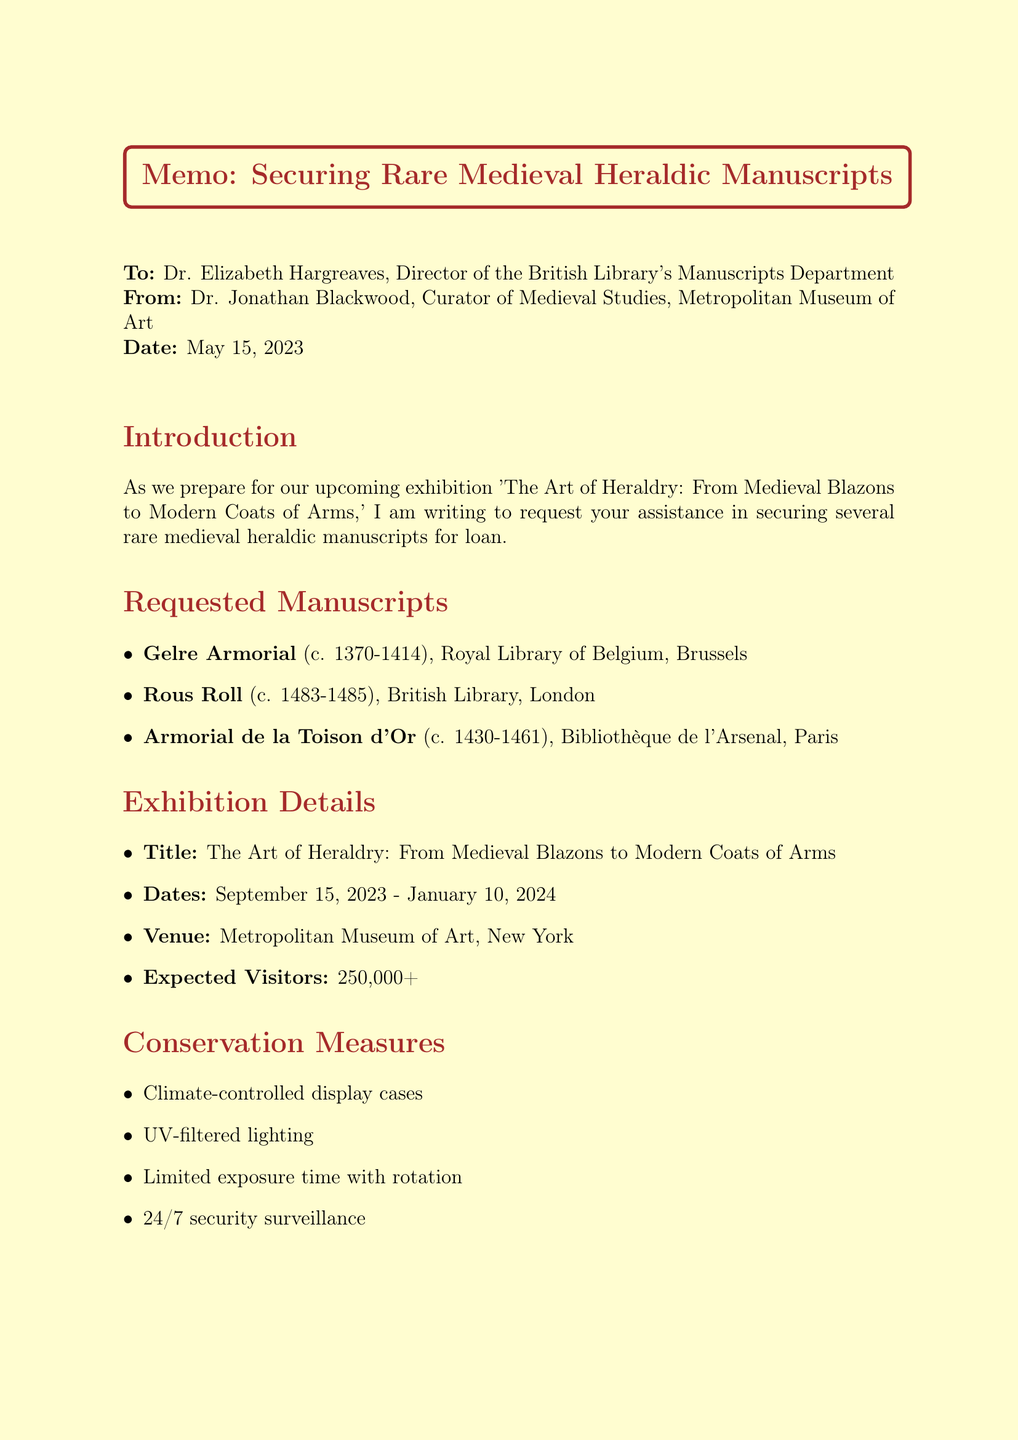what is the title of the exhibition? The title of the exhibition is mentioned in the document, specifically in the exhibition details section.
Answer: The Art of Heraldry: From Medieval Blazons to Modern Coats of Arms who is the recipient of the memo? The memo states the recipient's name at the beginning of the document.
Answer: Dr. Elizabeth Hargreaves what is the date range of the exhibition? The date range for the exhibition is outlined in the exhibition details section.
Answer: September 15, 2023 - January 10, 2024 how many expected visitors are there? The expected number of visitors is specified in the exhibition details section of the memo.
Answer: 250,000+ what conservation measure is mentioned for lighting? The conservation measures section of the document details specific measures including lighting.
Answer: UV-filtered lighting which manuscript is from the British Library? The requested manuscripts are listed along with their locations, one of which is the British Library.
Answer: Rous Roll what is a benefit of the loan mentioned in the memo? The loan benefits are outlined in a section of the document, highlighting several advantages.
Answer: Increased visibility and recognition for lending institutions who is the sender of the memo? The sender's name is provided at the beginning of the document.
Answer: Dr. Jonathan Blackwood how many manuscripts are requested for the exhibition? The number of requested manuscripts can be determined from the list provided in the document.
Answer: Three 